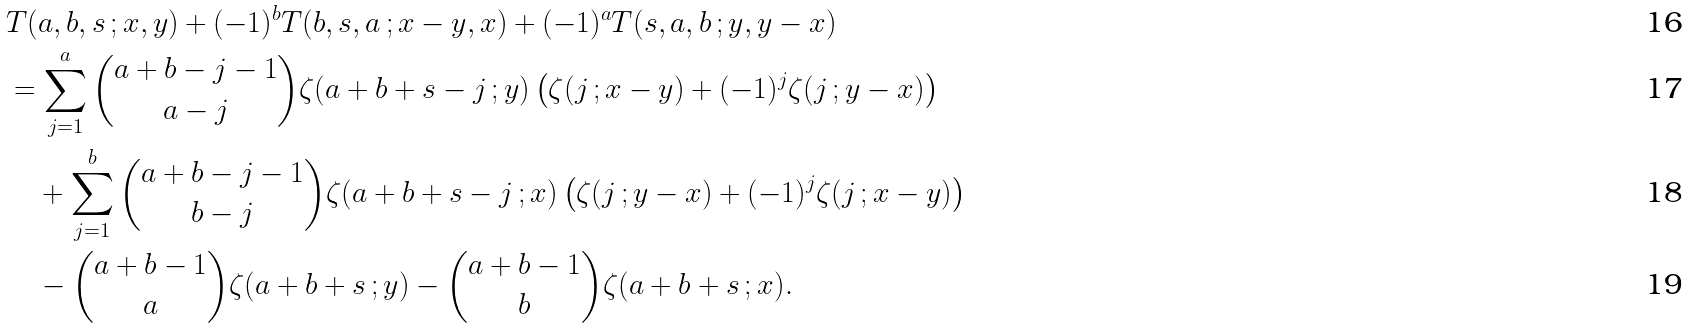Convert formula to latex. <formula><loc_0><loc_0><loc_500><loc_500>& T ( a , b , s \, ; x , y ) + ( - 1 ) ^ { b } T ( b , s , a \, ; x - y , x ) + ( - 1 ) ^ { a } T ( s , a , b \, ; y , y - x ) \\ & = \sum _ { j = 1 } ^ { a } \binom { a + b - j - 1 } { a - j } \zeta ( a + b + s - j \, ; y ) \left ( \zeta ( j \, ; x - y ) + ( - 1 ) ^ { j } \zeta ( j \, ; y - x ) \right ) \\ & \quad + \sum _ { j = 1 } ^ { b } \binom { a + b - j - 1 } { b - j } \zeta ( a + b + s - j \, ; x ) \left ( \zeta ( j \, ; y - x ) + ( - 1 ) ^ { j } \zeta ( j \, ; x - y ) \right ) \\ & \quad - \binom { a + b - 1 } { a } \zeta ( a + b + s \, ; y ) - \binom { a + b - 1 } { b } \zeta ( a + b + s \, ; x ) .</formula> 